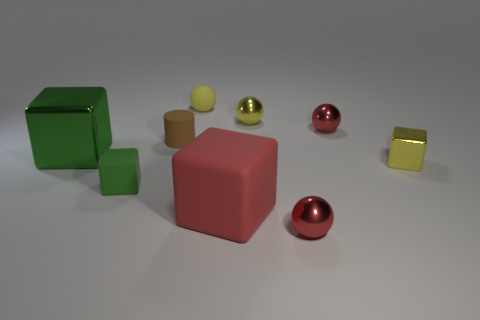How many yellow balls must be subtracted to get 1 yellow balls? 1 Subtract all small yellow shiny balls. How many balls are left? 3 Subtract all cubes. How many objects are left? 5 Subtract all red balls. How many balls are left? 2 Add 1 large red matte cubes. How many objects exist? 10 Subtract 3 spheres. How many spheres are left? 1 Subtract all cyan cylinders. Subtract all yellow balls. How many cylinders are left? 1 Subtract all green cubes. How many purple cylinders are left? 0 Subtract all tiny yellow objects. Subtract all rubber things. How many objects are left? 2 Add 4 small yellow objects. How many small yellow objects are left? 7 